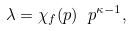Convert formula to latex. <formula><loc_0><loc_0><loc_500><loc_500>\lambda = \chi _ { f } ( p ) \ p ^ { \kappa - 1 } ,</formula> 